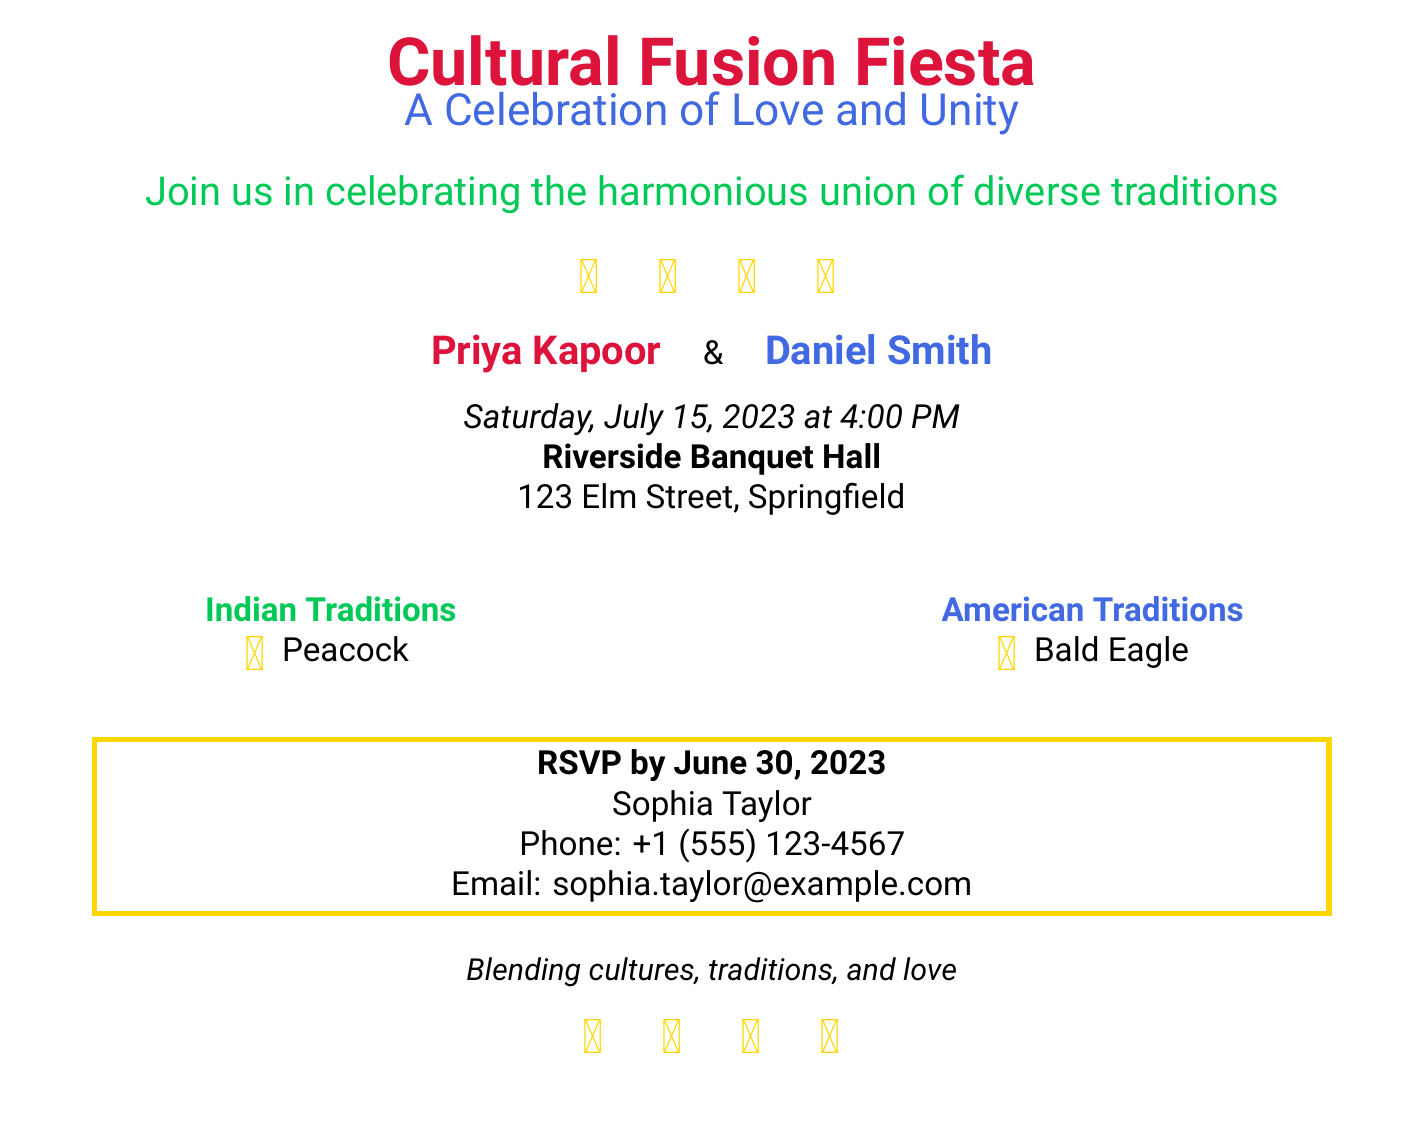What is the title of the invitation? The title, highlighted at the top of the invitation, is "Cultural Fusion Fiesta."
Answer: Cultural Fusion Fiesta Who are the couple getting married? The invitation explicitly mentions the names of the couple: Priya Kapoor and Daniel Smith.
Answer: Priya Kapoor and Daniel Smith What date and time is the wedding? The wedding date and time are specified in the invitation as "Saturday, July 15, 2023 at 4:00 PM."
Answer: Saturday, July 15, 2023 at 4:00 PM What is the RSVP deadline? The invitation states that RSVPs should be sent by June 30, 2023.
Answer: June 30, 2023 What is the location of the wedding? The wedding location is provided as "Riverside Banquet Hall, 123 Elm Street, Springfield."
Answer: Riverside Banquet Hall What cultural symbols are included in the design? The invitation features symbols representing several cultures: peace sign, dharmachakra, Star of David, and yin-yang.
Answer: ☮ ☸ ✡ ☯ What does the invitation aim to celebrate? The declaration in the invitation emphasizes the celebration of love and unity amongst diverse traditions.
Answer: Love and unity Which two traditions are highlighted in the document? The document focuses on "Indian Traditions" and "American Traditions."
Answer: Indian and American Traditions 